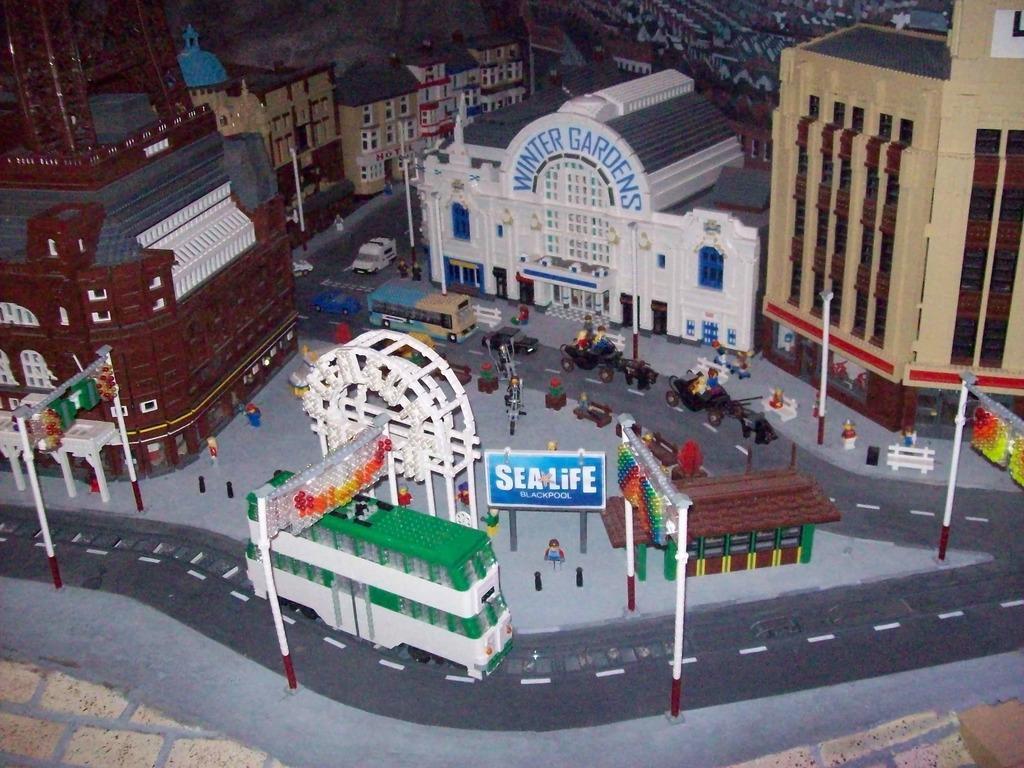How would you summarize this image in a sentence or two? In this picture we can see the model of the town. At the bottom we can see the bus which is near to the gate. Beside that we can see the boards. In the background we can see buildings. In front of the building we see many vehicles. On the right we can see the street lights, poles on the road. 